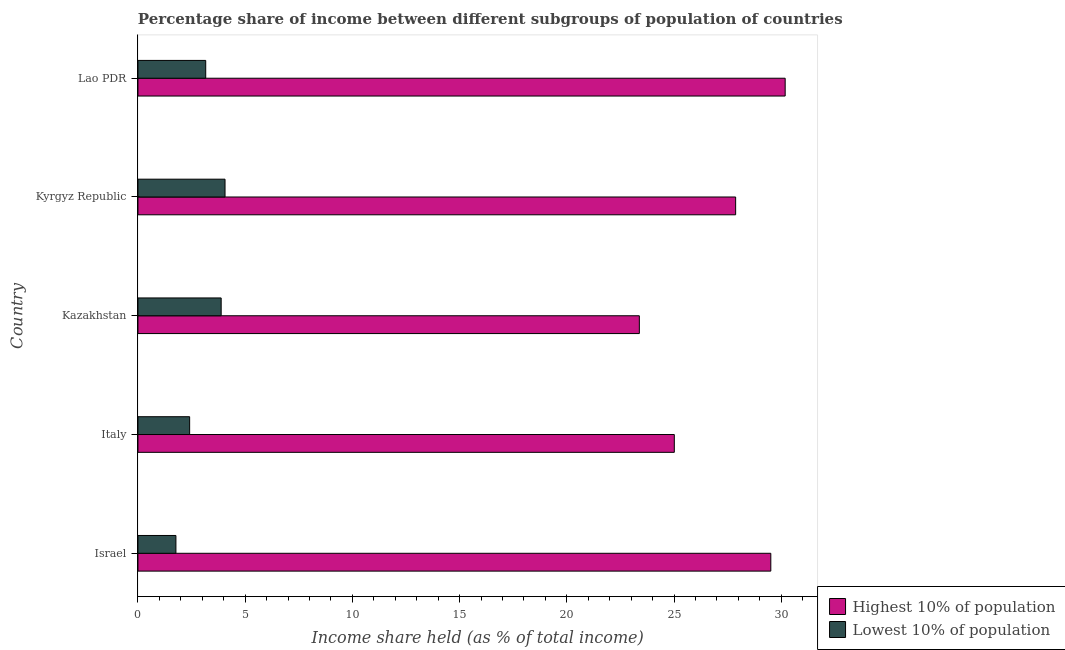How many different coloured bars are there?
Ensure brevity in your answer.  2. Are the number of bars per tick equal to the number of legend labels?
Give a very brief answer. Yes. How many bars are there on the 5th tick from the top?
Your answer should be compact. 2. What is the label of the 4th group of bars from the top?
Make the answer very short. Italy. In how many cases, is the number of bars for a given country not equal to the number of legend labels?
Give a very brief answer. 0. What is the income share held by highest 10% of the population in Lao PDR?
Give a very brief answer. 30.18. Across all countries, what is the maximum income share held by highest 10% of the population?
Your answer should be compact. 30.18. Across all countries, what is the minimum income share held by highest 10% of the population?
Offer a terse response. 23.38. In which country was the income share held by lowest 10% of the population maximum?
Provide a succinct answer. Kyrgyz Republic. In which country was the income share held by highest 10% of the population minimum?
Make the answer very short. Kazakhstan. What is the total income share held by highest 10% of the population in the graph?
Provide a short and direct response. 135.95. What is the difference between the income share held by highest 10% of the population in Israel and that in Kyrgyz Republic?
Ensure brevity in your answer.  1.64. What is the difference between the income share held by lowest 10% of the population in Kazakhstan and the income share held by highest 10% of the population in Italy?
Give a very brief answer. -21.13. What is the average income share held by lowest 10% of the population per country?
Your answer should be compact. 3.06. What is the difference between the income share held by highest 10% of the population and income share held by lowest 10% of the population in Kazakhstan?
Ensure brevity in your answer.  19.5. In how many countries, is the income share held by highest 10% of the population greater than 14 %?
Make the answer very short. 5. What is the ratio of the income share held by highest 10% of the population in Kyrgyz Republic to that in Lao PDR?
Ensure brevity in your answer.  0.92. What is the difference between the highest and the second highest income share held by highest 10% of the population?
Give a very brief answer. 0.67. What is the difference between the highest and the lowest income share held by lowest 10% of the population?
Your answer should be compact. 2.29. Is the sum of the income share held by lowest 10% of the population in Israel and Kyrgyz Republic greater than the maximum income share held by highest 10% of the population across all countries?
Make the answer very short. No. What does the 1st bar from the top in Kyrgyz Republic represents?
Ensure brevity in your answer.  Lowest 10% of population. What does the 2nd bar from the bottom in Kazakhstan represents?
Give a very brief answer. Lowest 10% of population. How many bars are there?
Give a very brief answer. 10. Are all the bars in the graph horizontal?
Offer a very short reply. Yes. How many countries are there in the graph?
Give a very brief answer. 5. Does the graph contain any zero values?
Provide a short and direct response. No. Where does the legend appear in the graph?
Provide a succinct answer. Bottom right. How are the legend labels stacked?
Ensure brevity in your answer.  Vertical. What is the title of the graph?
Keep it short and to the point. Percentage share of income between different subgroups of population of countries. What is the label or title of the X-axis?
Make the answer very short. Income share held (as % of total income). What is the label or title of the Y-axis?
Make the answer very short. Country. What is the Income share held (as % of total income) in Highest 10% of population in Israel?
Provide a succinct answer. 29.51. What is the Income share held (as % of total income) in Lowest 10% of population in Israel?
Your answer should be compact. 1.77. What is the Income share held (as % of total income) of Highest 10% of population in Italy?
Provide a short and direct response. 25.01. What is the Income share held (as % of total income) of Lowest 10% of population in Italy?
Your response must be concise. 2.41. What is the Income share held (as % of total income) of Highest 10% of population in Kazakhstan?
Your response must be concise. 23.38. What is the Income share held (as % of total income) of Lowest 10% of population in Kazakhstan?
Your response must be concise. 3.88. What is the Income share held (as % of total income) of Highest 10% of population in Kyrgyz Republic?
Your response must be concise. 27.87. What is the Income share held (as % of total income) of Lowest 10% of population in Kyrgyz Republic?
Offer a terse response. 4.06. What is the Income share held (as % of total income) of Highest 10% of population in Lao PDR?
Ensure brevity in your answer.  30.18. What is the Income share held (as % of total income) in Lowest 10% of population in Lao PDR?
Offer a very short reply. 3.16. Across all countries, what is the maximum Income share held (as % of total income) of Highest 10% of population?
Keep it short and to the point. 30.18. Across all countries, what is the maximum Income share held (as % of total income) in Lowest 10% of population?
Offer a very short reply. 4.06. Across all countries, what is the minimum Income share held (as % of total income) of Highest 10% of population?
Your answer should be very brief. 23.38. Across all countries, what is the minimum Income share held (as % of total income) in Lowest 10% of population?
Make the answer very short. 1.77. What is the total Income share held (as % of total income) in Highest 10% of population in the graph?
Make the answer very short. 135.95. What is the total Income share held (as % of total income) in Lowest 10% of population in the graph?
Your response must be concise. 15.28. What is the difference between the Income share held (as % of total income) in Highest 10% of population in Israel and that in Italy?
Give a very brief answer. 4.5. What is the difference between the Income share held (as % of total income) in Lowest 10% of population in Israel and that in Italy?
Offer a very short reply. -0.64. What is the difference between the Income share held (as % of total income) of Highest 10% of population in Israel and that in Kazakhstan?
Provide a short and direct response. 6.13. What is the difference between the Income share held (as % of total income) of Lowest 10% of population in Israel and that in Kazakhstan?
Make the answer very short. -2.11. What is the difference between the Income share held (as % of total income) in Highest 10% of population in Israel and that in Kyrgyz Republic?
Your answer should be very brief. 1.64. What is the difference between the Income share held (as % of total income) of Lowest 10% of population in Israel and that in Kyrgyz Republic?
Offer a very short reply. -2.29. What is the difference between the Income share held (as % of total income) in Highest 10% of population in Israel and that in Lao PDR?
Your response must be concise. -0.67. What is the difference between the Income share held (as % of total income) of Lowest 10% of population in Israel and that in Lao PDR?
Keep it short and to the point. -1.39. What is the difference between the Income share held (as % of total income) in Highest 10% of population in Italy and that in Kazakhstan?
Offer a terse response. 1.63. What is the difference between the Income share held (as % of total income) of Lowest 10% of population in Italy and that in Kazakhstan?
Provide a succinct answer. -1.47. What is the difference between the Income share held (as % of total income) of Highest 10% of population in Italy and that in Kyrgyz Republic?
Keep it short and to the point. -2.86. What is the difference between the Income share held (as % of total income) in Lowest 10% of population in Italy and that in Kyrgyz Republic?
Your answer should be very brief. -1.65. What is the difference between the Income share held (as % of total income) of Highest 10% of population in Italy and that in Lao PDR?
Keep it short and to the point. -5.17. What is the difference between the Income share held (as % of total income) in Lowest 10% of population in Italy and that in Lao PDR?
Your response must be concise. -0.75. What is the difference between the Income share held (as % of total income) in Highest 10% of population in Kazakhstan and that in Kyrgyz Republic?
Ensure brevity in your answer.  -4.49. What is the difference between the Income share held (as % of total income) of Lowest 10% of population in Kazakhstan and that in Kyrgyz Republic?
Offer a terse response. -0.18. What is the difference between the Income share held (as % of total income) in Highest 10% of population in Kazakhstan and that in Lao PDR?
Your answer should be compact. -6.8. What is the difference between the Income share held (as % of total income) in Lowest 10% of population in Kazakhstan and that in Lao PDR?
Make the answer very short. 0.72. What is the difference between the Income share held (as % of total income) in Highest 10% of population in Kyrgyz Republic and that in Lao PDR?
Give a very brief answer. -2.31. What is the difference between the Income share held (as % of total income) in Lowest 10% of population in Kyrgyz Republic and that in Lao PDR?
Provide a short and direct response. 0.9. What is the difference between the Income share held (as % of total income) of Highest 10% of population in Israel and the Income share held (as % of total income) of Lowest 10% of population in Italy?
Offer a terse response. 27.1. What is the difference between the Income share held (as % of total income) in Highest 10% of population in Israel and the Income share held (as % of total income) in Lowest 10% of population in Kazakhstan?
Provide a short and direct response. 25.63. What is the difference between the Income share held (as % of total income) of Highest 10% of population in Israel and the Income share held (as % of total income) of Lowest 10% of population in Kyrgyz Republic?
Your answer should be very brief. 25.45. What is the difference between the Income share held (as % of total income) in Highest 10% of population in Israel and the Income share held (as % of total income) in Lowest 10% of population in Lao PDR?
Ensure brevity in your answer.  26.35. What is the difference between the Income share held (as % of total income) in Highest 10% of population in Italy and the Income share held (as % of total income) in Lowest 10% of population in Kazakhstan?
Give a very brief answer. 21.13. What is the difference between the Income share held (as % of total income) in Highest 10% of population in Italy and the Income share held (as % of total income) in Lowest 10% of population in Kyrgyz Republic?
Your answer should be very brief. 20.95. What is the difference between the Income share held (as % of total income) of Highest 10% of population in Italy and the Income share held (as % of total income) of Lowest 10% of population in Lao PDR?
Provide a succinct answer. 21.85. What is the difference between the Income share held (as % of total income) in Highest 10% of population in Kazakhstan and the Income share held (as % of total income) in Lowest 10% of population in Kyrgyz Republic?
Your response must be concise. 19.32. What is the difference between the Income share held (as % of total income) of Highest 10% of population in Kazakhstan and the Income share held (as % of total income) of Lowest 10% of population in Lao PDR?
Offer a terse response. 20.22. What is the difference between the Income share held (as % of total income) of Highest 10% of population in Kyrgyz Republic and the Income share held (as % of total income) of Lowest 10% of population in Lao PDR?
Give a very brief answer. 24.71. What is the average Income share held (as % of total income) in Highest 10% of population per country?
Give a very brief answer. 27.19. What is the average Income share held (as % of total income) in Lowest 10% of population per country?
Make the answer very short. 3.06. What is the difference between the Income share held (as % of total income) of Highest 10% of population and Income share held (as % of total income) of Lowest 10% of population in Israel?
Give a very brief answer. 27.74. What is the difference between the Income share held (as % of total income) of Highest 10% of population and Income share held (as % of total income) of Lowest 10% of population in Italy?
Your response must be concise. 22.6. What is the difference between the Income share held (as % of total income) in Highest 10% of population and Income share held (as % of total income) in Lowest 10% of population in Kyrgyz Republic?
Make the answer very short. 23.81. What is the difference between the Income share held (as % of total income) of Highest 10% of population and Income share held (as % of total income) of Lowest 10% of population in Lao PDR?
Provide a short and direct response. 27.02. What is the ratio of the Income share held (as % of total income) of Highest 10% of population in Israel to that in Italy?
Provide a short and direct response. 1.18. What is the ratio of the Income share held (as % of total income) in Lowest 10% of population in Israel to that in Italy?
Offer a very short reply. 0.73. What is the ratio of the Income share held (as % of total income) in Highest 10% of population in Israel to that in Kazakhstan?
Your response must be concise. 1.26. What is the ratio of the Income share held (as % of total income) in Lowest 10% of population in Israel to that in Kazakhstan?
Ensure brevity in your answer.  0.46. What is the ratio of the Income share held (as % of total income) in Highest 10% of population in Israel to that in Kyrgyz Republic?
Offer a very short reply. 1.06. What is the ratio of the Income share held (as % of total income) in Lowest 10% of population in Israel to that in Kyrgyz Republic?
Your answer should be very brief. 0.44. What is the ratio of the Income share held (as % of total income) in Highest 10% of population in Israel to that in Lao PDR?
Give a very brief answer. 0.98. What is the ratio of the Income share held (as % of total income) in Lowest 10% of population in Israel to that in Lao PDR?
Offer a terse response. 0.56. What is the ratio of the Income share held (as % of total income) in Highest 10% of population in Italy to that in Kazakhstan?
Your response must be concise. 1.07. What is the ratio of the Income share held (as % of total income) in Lowest 10% of population in Italy to that in Kazakhstan?
Your response must be concise. 0.62. What is the ratio of the Income share held (as % of total income) in Highest 10% of population in Italy to that in Kyrgyz Republic?
Keep it short and to the point. 0.9. What is the ratio of the Income share held (as % of total income) of Lowest 10% of population in Italy to that in Kyrgyz Republic?
Offer a terse response. 0.59. What is the ratio of the Income share held (as % of total income) of Highest 10% of population in Italy to that in Lao PDR?
Your answer should be very brief. 0.83. What is the ratio of the Income share held (as % of total income) of Lowest 10% of population in Italy to that in Lao PDR?
Ensure brevity in your answer.  0.76. What is the ratio of the Income share held (as % of total income) in Highest 10% of population in Kazakhstan to that in Kyrgyz Republic?
Ensure brevity in your answer.  0.84. What is the ratio of the Income share held (as % of total income) in Lowest 10% of population in Kazakhstan to that in Kyrgyz Republic?
Keep it short and to the point. 0.96. What is the ratio of the Income share held (as % of total income) of Highest 10% of population in Kazakhstan to that in Lao PDR?
Offer a very short reply. 0.77. What is the ratio of the Income share held (as % of total income) in Lowest 10% of population in Kazakhstan to that in Lao PDR?
Your answer should be very brief. 1.23. What is the ratio of the Income share held (as % of total income) in Highest 10% of population in Kyrgyz Republic to that in Lao PDR?
Offer a very short reply. 0.92. What is the ratio of the Income share held (as % of total income) in Lowest 10% of population in Kyrgyz Republic to that in Lao PDR?
Your answer should be very brief. 1.28. What is the difference between the highest and the second highest Income share held (as % of total income) in Highest 10% of population?
Offer a terse response. 0.67. What is the difference between the highest and the second highest Income share held (as % of total income) of Lowest 10% of population?
Your answer should be compact. 0.18. What is the difference between the highest and the lowest Income share held (as % of total income) of Lowest 10% of population?
Your answer should be compact. 2.29. 